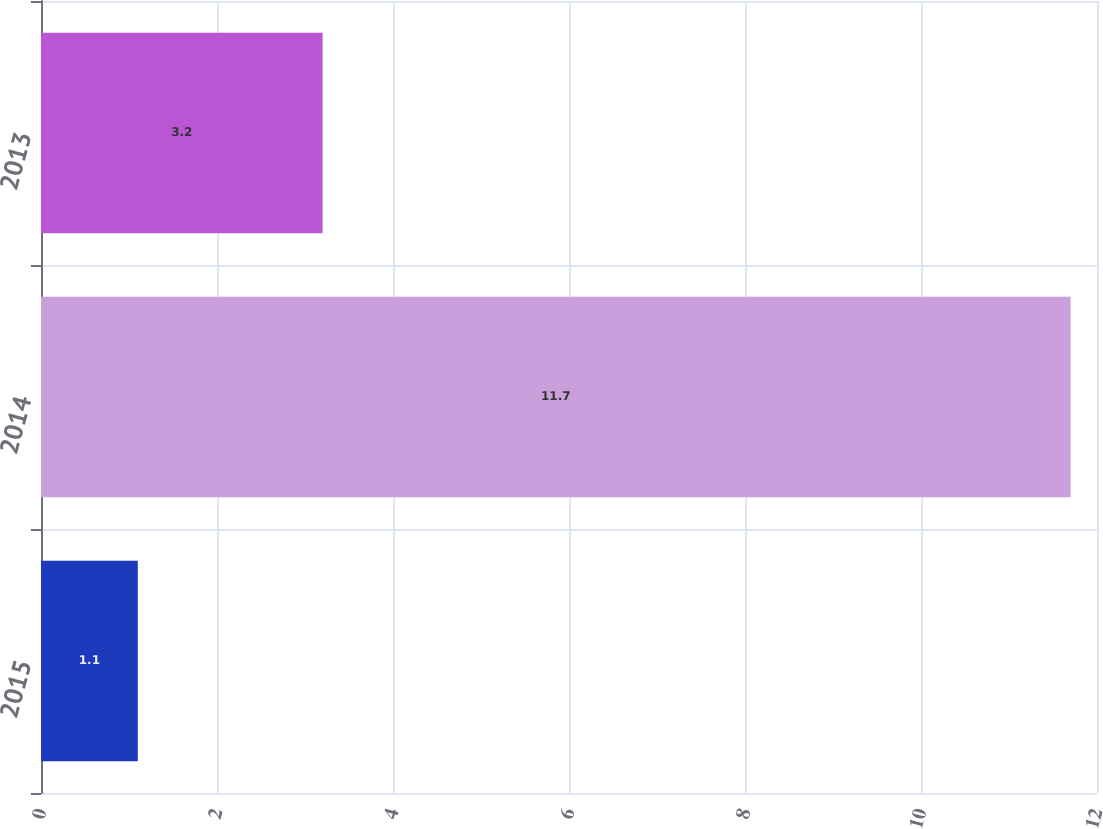Convert chart. <chart><loc_0><loc_0><loc_500><loc_500><bar_chart><fcel>2015<fcel>2014<fcel>2013<nl><fcel>1.1<fcel>11.7<fcel>3.2<nl></chart> 